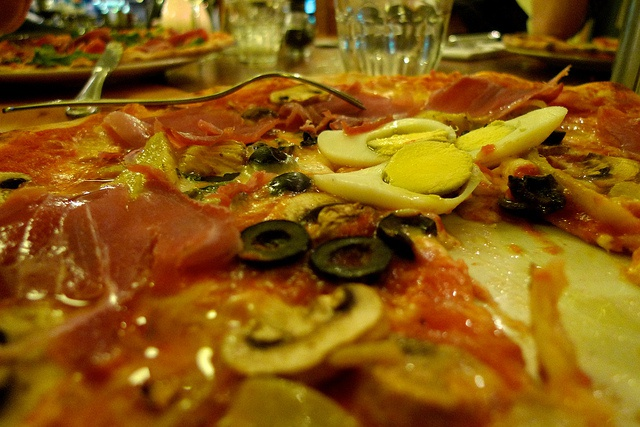Describe the objects in this image and their specific colors. I can see pizza in olive and maroon tones, cup in maroon and olive tones, pizza in maroon, olive, and black tones, fork in maroon, olive, and black tones, and pizza in maroon, olive, and black tones in this image. 